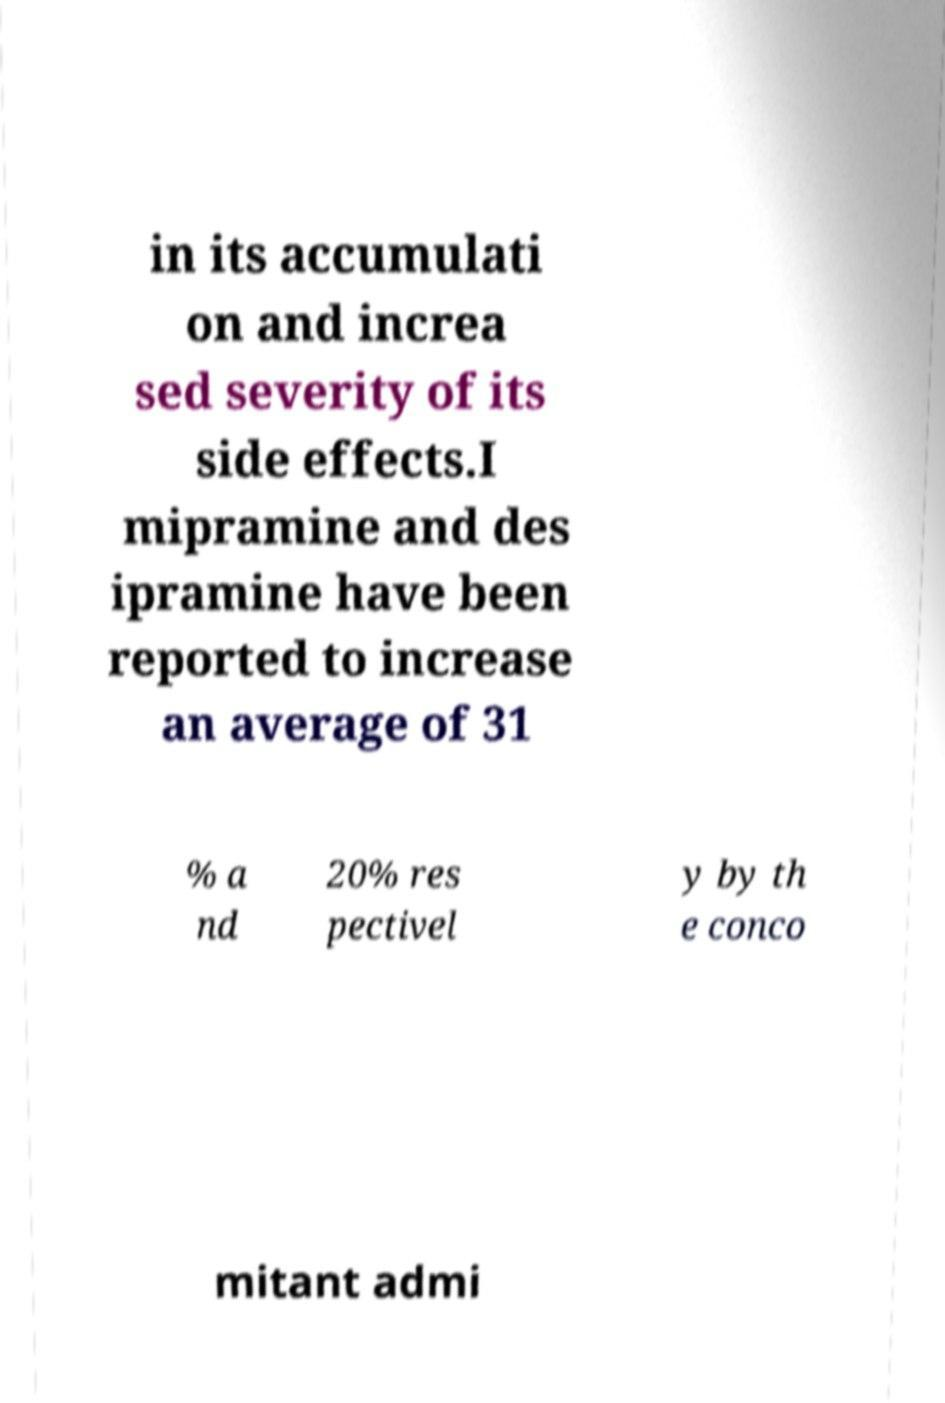Can you read and provide the text displayed in the image?This photo seems to have some interesting text. Can you extract and type it out for me? in its accumulati on and increa sed severity of its side effects.I mipramine and des ipramine have been reported to increase an average of 31 % a nd 20% res pectivel y by th e conco mitant admi 